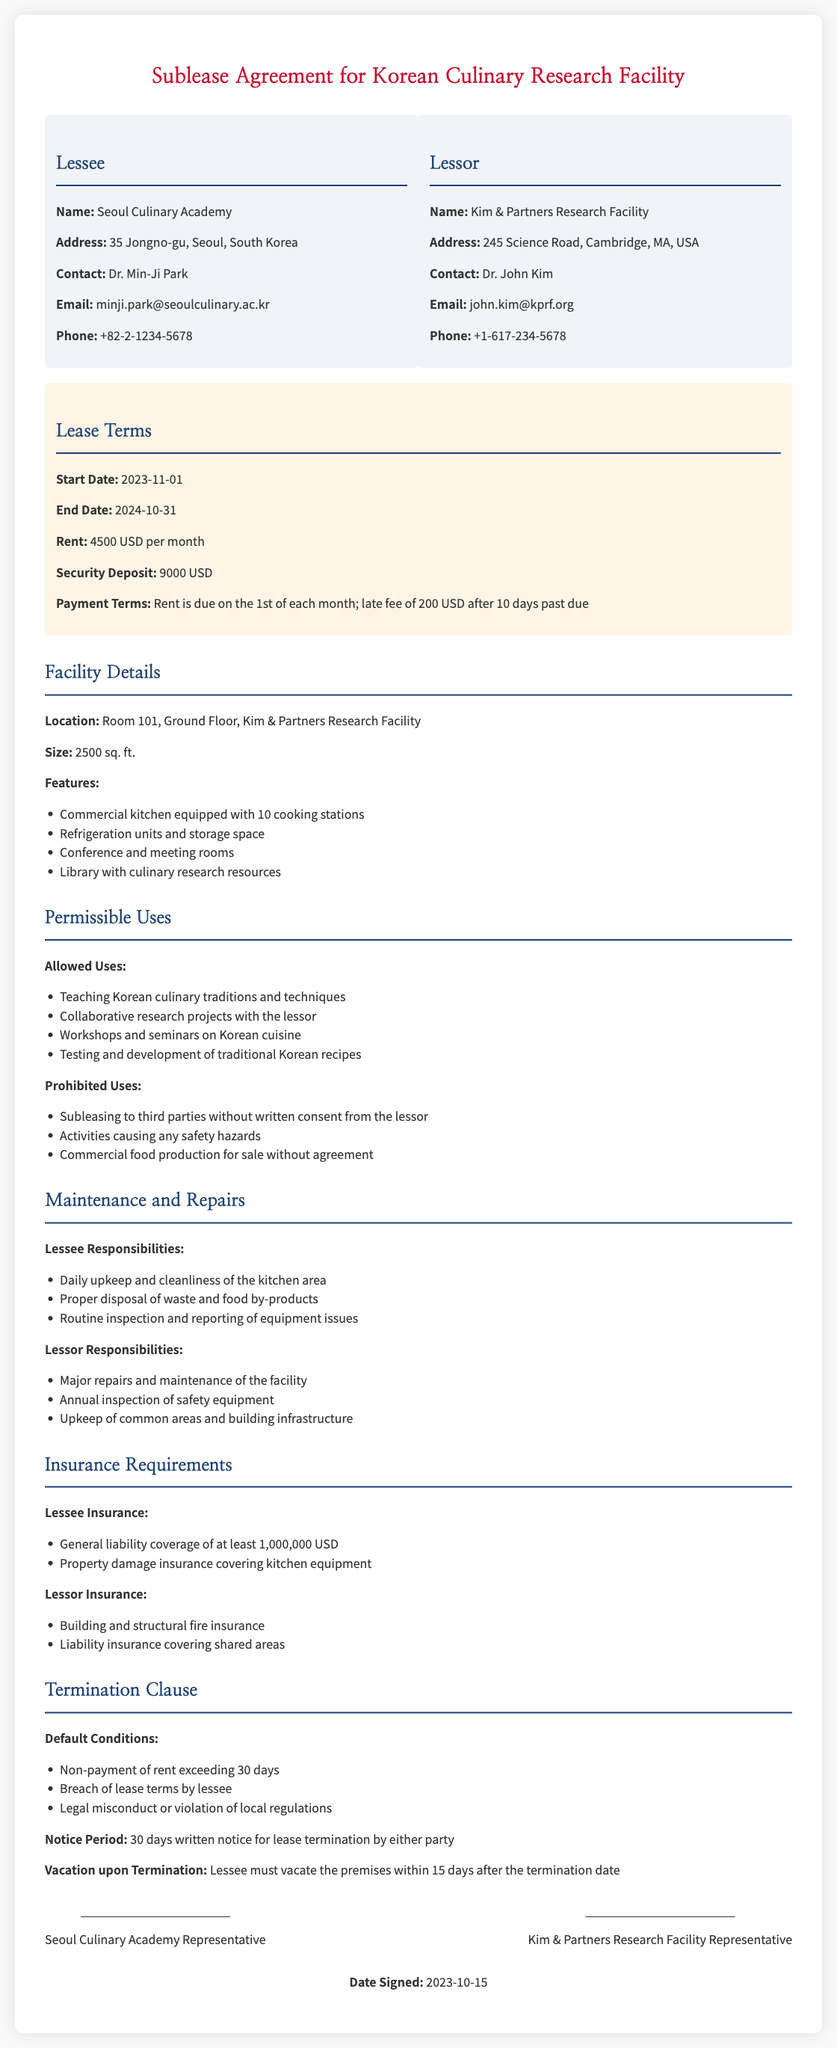What is the name of the lessee? The lessee is identified as the Seoul Culinary Academy in the document.
Answer: Seoul Culinary Academy What is the rent amount per month? The document specifies the rent amount as 4500 USD per month.
Answer: 4500 USD What is the length of the lease term? The lease term begins on 2023-11-01 and ends on 2024-10-31, which is a total of 12 months.
Answer: 12 months What are the prohibited uses listed in the agreement? The document lists specific prohibited uses that include subleasing without consent and activities causing safety hazards.
Answer: Subleasing to third parties without written consent from the lessor; Activities causing any safety hazards; Commercial food production for sale without agreement What is the notice period required for lease termination? The notice period for lease termination is specified as 30 days written notice from either party.
Answer: 30 days Who is responsible for major repairs and maintenance of the facility? The document states that the lessor is responsible for major repairs and maintenance.
Answer: Lessor What is the required general liability coverage for the lessee? The document specifies that the lessee needs to have general liability coverage of at least 1,000,000 USD.
Answer: 1,000,000 USD What constitutes a default condition in the lease? Default conditions include non-payment of rent exceeding 30 days and breach of lease terms by lessee, among other factors.
Answer: Non-payment of rent exceeding 30 days; Breach of lease terms by lessee; Legal misconduct or violation of local regulations What is the address of the lessor? The lessor's address is provided as 245 Science Road, Cambridge, MA, USA.
Answer: 245 Science Road, Cambridge, MA, USA 